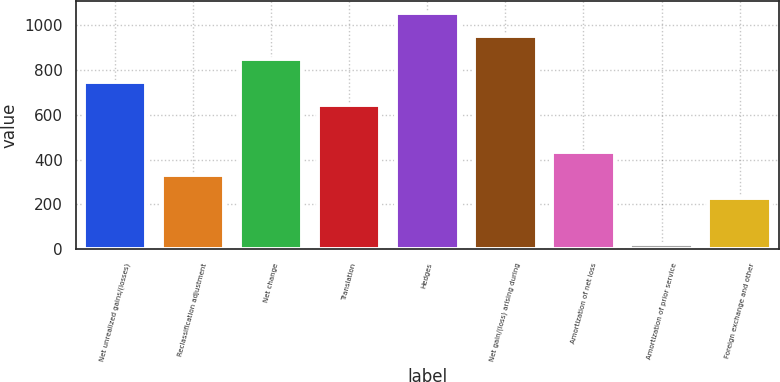Convert chart to OTSL. <chart><loc_0><loc_0><loc_500><loc_500><bar_chart><fcel>Net unrealized gains/(losses)<fcel>Reclassification adjustment<fcel>Net change<fcel>Translation<fcel>Hedges<fcel>Net gain/(loss) arising during<fcel>Amortization of net loss<fcel>Amortization of prior service<fcel>Foreign exchange and other<nl><fcel>746.1<fcel>332.9<fcel>849.4<fcel>642.8<fcel>1056<fcel>952.7<fcel>436.2<fcel>23<fcel>229.6<nl></chart> 